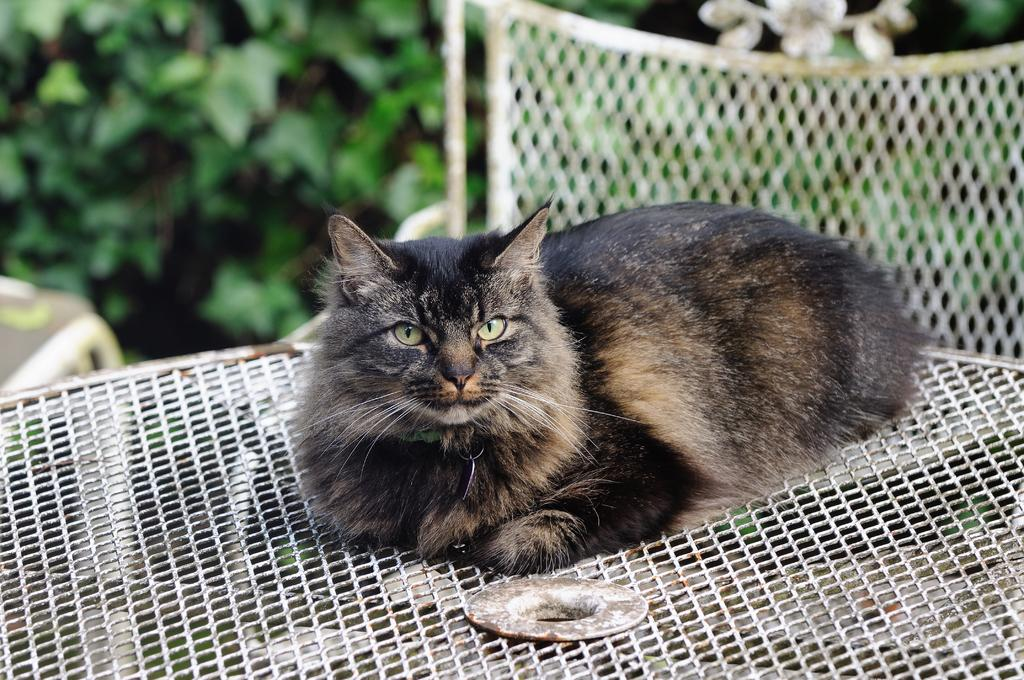What animal can be seen in the image? There is a cat in the image. Where is the cat sitting? The cat is sitting on a mesh. What can be seen in the distance in the image? There are trees visible in the background of the image. Is the cat wearing a veil in the image? No, the cat is not wearing a veil in the image. Can you tell if the cat is an expert in any field? No, the image does not provide any information about the cat's expertise or abilities. 